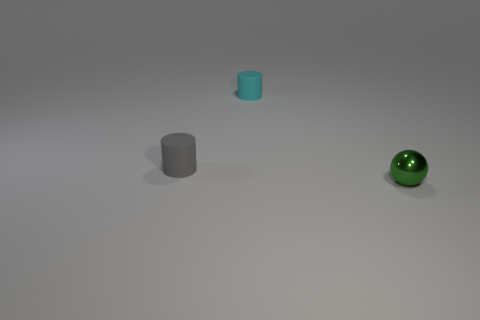Add 1 big blue metal cylinders. How many objects exist? 4 Subtract all cyan cylinders. How many cylinders are left? 1 Subtract 1 spheres. How many spheres are left? 0 Subtract all gray balls. Subtract all gray cylinders. How many balls are left? 1 Subtract all tiny brown matte balls. Subtract all cyan things. How many objects are left? 2 Add 2 gray objects. How many gray objects are left? 3 Add 2 red shiny blocks. How many red shiny blocks exist? 2 Subtract 0 purple blocks. How many objects are left? 3 Subtract all spheres. How many objects are left? 2 